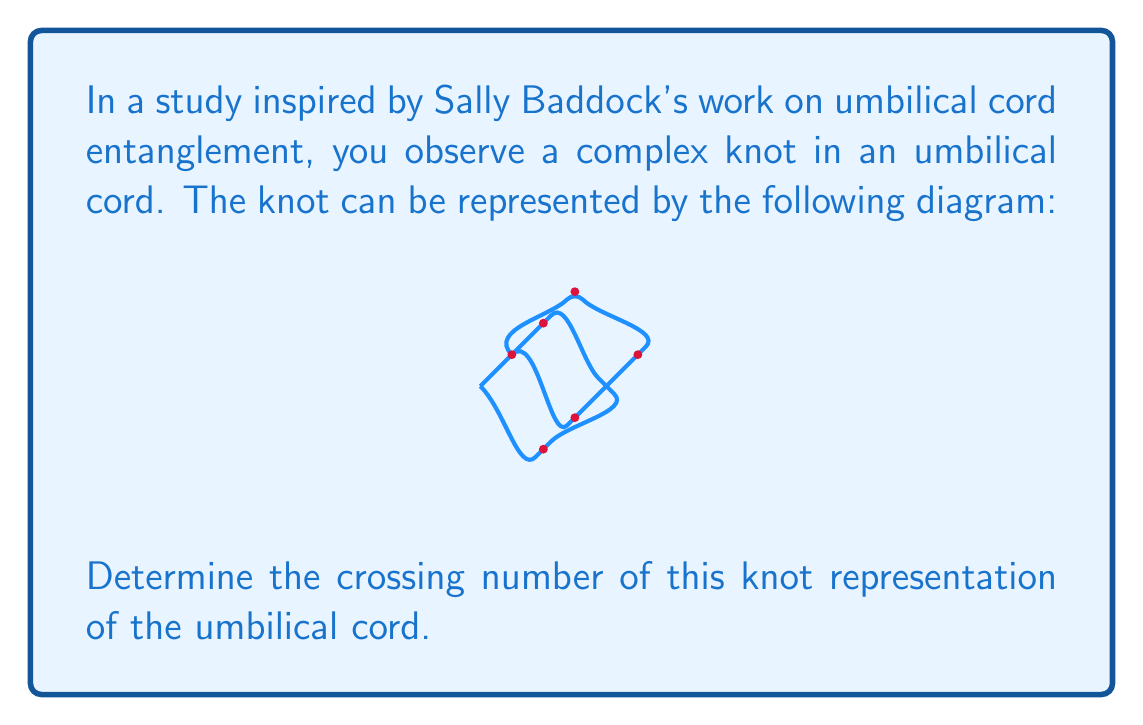Help me with this question. To determine the crossing number of this knot representation, we need to follow these steps:

1) First, let's recall that the crossing number of a knot is the minimum number of crossings that occur in any projection of the knot onto a plane.

2) In the given diagram, we need to count the number of times the cord crosses over itself. Each crossing point represents a place where one part of the cord passes either over or under another part.

3) Let's count the crossings:
   - There's a crossing near the bottom of the diagram
   - There's a crossing near the top of the diagram
   - There's a crossing on the left side
   - There's a crossing on the right side

4) In total, we can count 4 distinct crossing points in this projection of the knot.

5) However, it's important to note that this might not be the minimal representation of the knot. In knot theory, we're interested in the minimum number of crossings possible for any projection of the knot.

6) In this case, given the relatively simple nature of the knot, it's likely that this representation is indeed minimal. More complex knots might require careful analysis or even mathematical proofs to determine if a given representation is minimal.

7) Therefore, based on the information provided in the diagram, we can conclude that the crossing number of this knot representation is 4.

This analysis of umbilical cord entanglement, inspired by Sally Baddock's work, can provide valuable insights into potential risks during childbirth, which is crucial knowledge for a midwifery student.
Answer: 4 